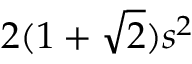Convert formula to latex. <formula><loc_0><loc_0><loc_500><loc_500>2 ( 1 + { \sqrt { 2 } } ) s ^ { 2 } \,</formula> 